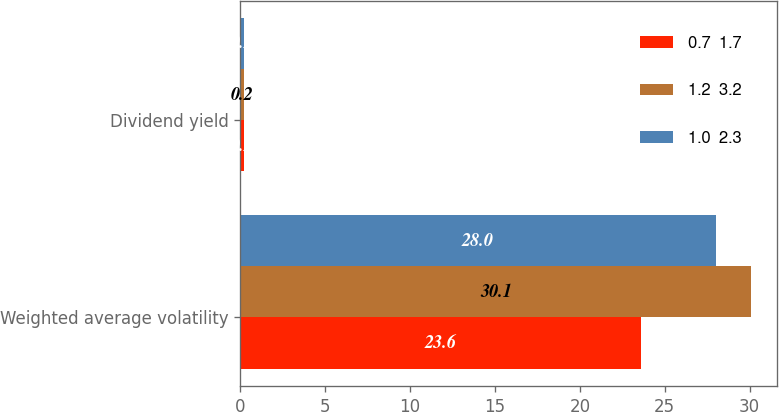Convert chart to OTSL. <chart><loc_0><loc_0><loc_500><loc_500><stacked_bar_chart><ecel><fcel>Weighted average volatility<fcel>Dividend yield<nl><fcel>0.7  1.7<fcel>23.6<fcel>0.2<nl><fcel>1.2  3.2<fcel>30.1<fcel>0.2<nl><fcel>1.0  2.3<fcel>28<fcel>0.2<nl></chart> 